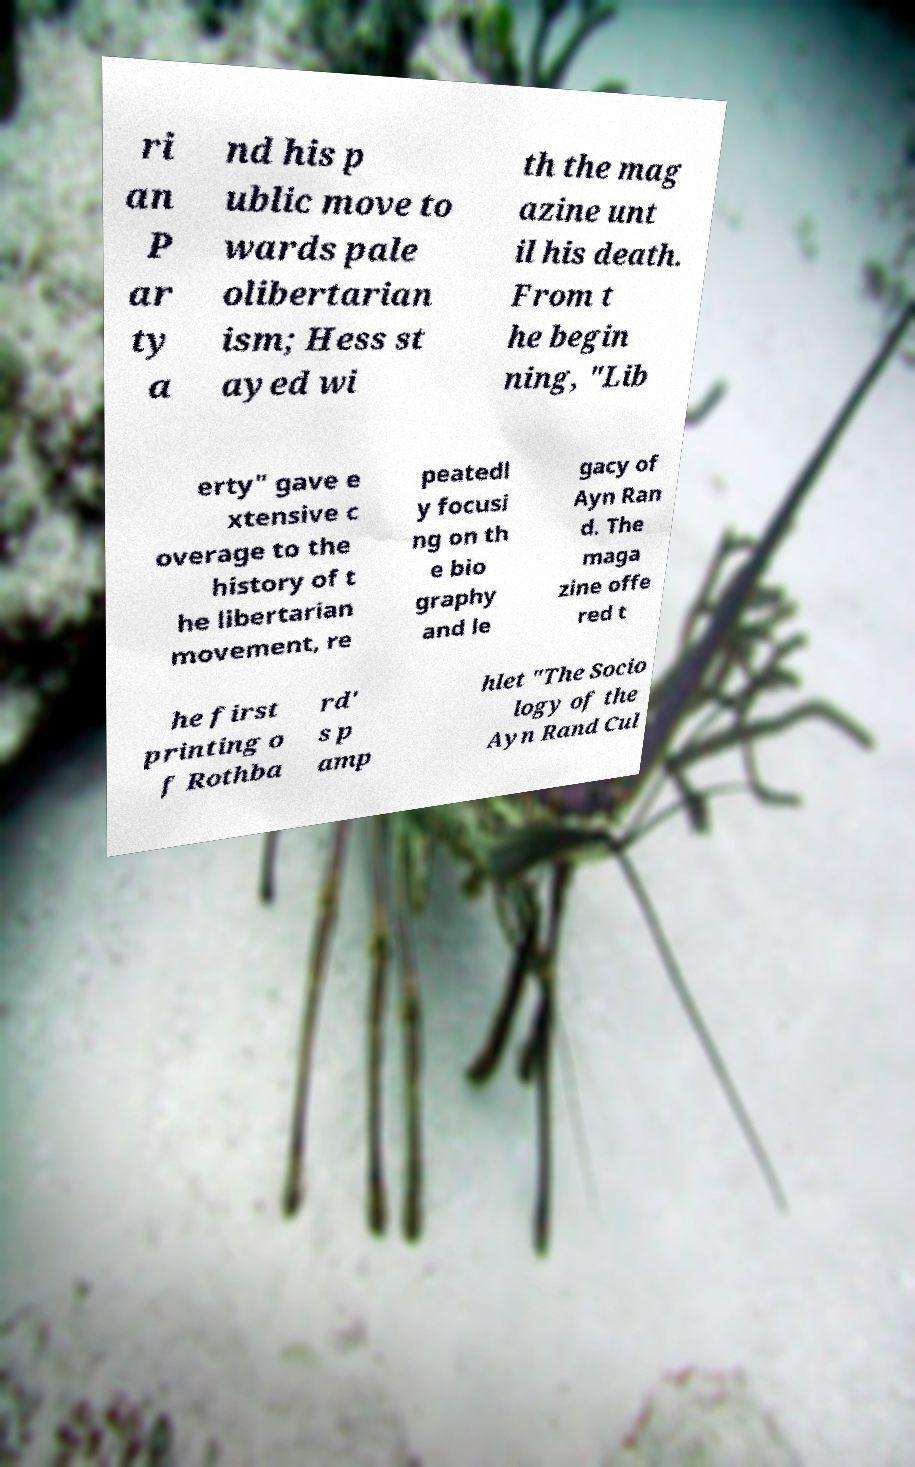Please identify and transcribe the text found in this image. ri an P ar ty a nd his p ublic move to wards pale olibertarian ism; Hess st ayed wi th the mag azine unt il his death. From t he begin ning, "Lib erty" gave e xtensive c overage to the history of t he libertarian movement, re peatedl y focusi ng on th e bio graphy and le gacy of Ayn Ran d. The maga zine offe red t he first printing o f Rothba rd' s p amp hlet "The Socio logy of the Ayn Rand Cul 